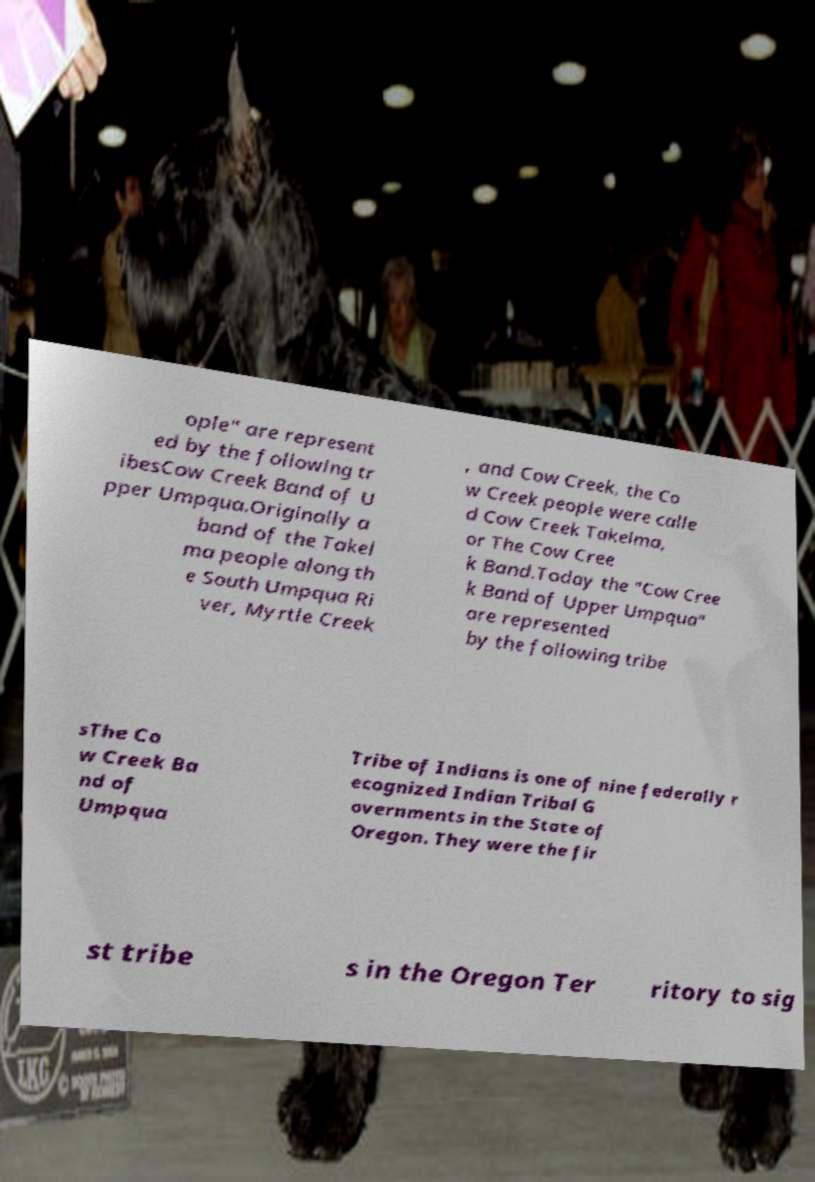Please read and relay the text visible in this image. What does it say? ople" are represent ed by the following tr ibesCow Creek Band of U pper Umpqua.Originally a band of the Takel ma people along th e South Umpqua Ri ver, Myrtle Creek , and Cow Creek, the Co w Creek people were calle d Cow Creek Takelma, or The Cow Cree k Band.Today the "Cow Cree k Band of Upper Umpqua" are represented by the following tribe sThe Co w Creek Ba nd of Umpqua Tribe of Indians is one of nine federally r ecognized Indian Tribal G overnments in the State of Oregon. They were the fir st tribe s in the Oregon Ter ritory to sig 